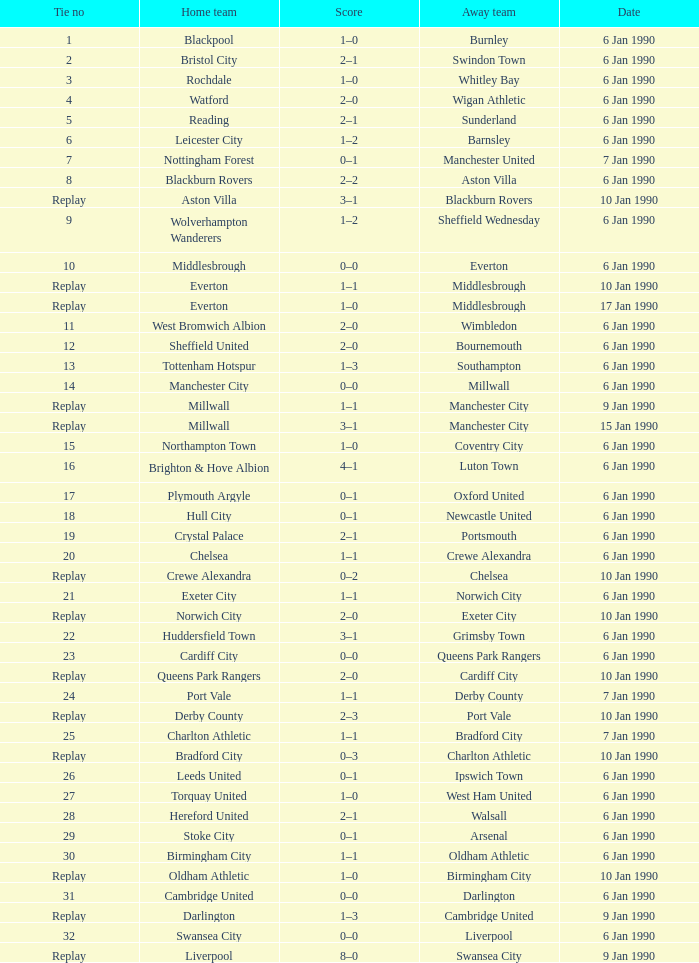What is the score of the game against away team exeter city on 10 jan 1990? 2–0. Can you parse all the data within this table? {'header': ['Tie no', 'Home team', 'Score', 'Away team', 'Date'], 'rows': [['1', 'Blackpool', '1–0', 'Burnley', '6 Jan 1990'], ['2', 'Bristol City', '2–1', 'Swindon Town', '6 Jan 1990'], ['3', 'Rochdale', '1–0', 'Whitley Bay', '6 Jan 1990'], ['4', 'Watford', '2–0', 'Wigan Athletic', '6 Jan 1990'], ['5', 'Reading', '2–1', 'Sunderland', '6 Jan 1990'], ['6', 'Leicester City', '1–2', 'Barnsley', '6 Jan 1990'], ['7', 'Nottingham Forest', '0–1', 'Manchester United', '7 Jan 1990'], ['8', 'Blackburn Rovers', '2–2', 'Aston Villa', '6 Jan 1990'], ['Replay', 'Aston Villa', '3–1', 'Blackburn Rovers', '10 Jan 1990'], ['9', 'Wolverhampton Wanderers', '1–2', 'Sheffield Wednesday', '6 Jan 1990'], ['10', 'Middlesbrough', '0–0', 'Everton', '6 Jan 1990'], ['Replay', 'Everton', '1–1', 'Middlesbrough', '10 Jan 1990'], ['Replay', 'Everton', '1–0', 'Middlesbrough', '17 Jan 1990'], ['11', 'West Bromwich Albion', '2–0', 'Wimbledon', '6 Jan 1990'], ['12', 'Sheffield United', '2–0', 'Bournemouth', '6 Jan 1990'], ['13', 'Tottenham Hotspur', '1–3', 'Southampton', '6 Jan 1990'], ['14', 'Manchester City', '0–0', 'Millwall', '6 Jan 1990'], ['Replay', 'Millwall', '1–1', 'Manchester City', '9 Jan 1990'], ['Replay', 'Millwall', '3–1', 'Manchester City', '15 Jan 1990'], ['15', 'Northampton Town', '1–0', 'Coventry City', '6 Jan 1990'], ['16', 'Brighton & Hove Albion', '4–1', 'Luton Town', '6 Jan 1990'], ['17', 'Plymouth Argyle', '0–1', 'Oxford United', '6 Jan 1990'], ['18', 'Hull City', '0–1', 'Newcastle United', '6 Jan 1990'], ['19', 'Crystal Palace', '2–1', 'Portsmouth', '6 Jan 1990'], ['20', 'Chelsea', '1–1', 'Crewe Alexandra', '6 Jan 1990'], ['Replay', 'Crewe Alexandra', '0–2', 'Chelsea', '10 Jan 1990'], ['21', 'Exeter City', '1–1', 'Norwich City', '6 Jan 1990'], ['Replay', 'Norwich City', '2–0', 'Exeter City', '10 Jan 1990'], ['22', 'Huddersfield Town', '3–1', 'Grimsby Town', '6 Jan 1990'], ['23', 'Cardiff City', '0–0', 'Queens Park Rangers', '6 Jan 1990'], ['Replay', 'Queens Park Rangers', '2–0', 'Cardiff City', '10 Jan 1990'], ['24', 'Port Vale', '1–1', 'Derby County', '7 Jan 1990'], ['Replay', 'Derby County', '2–3', 'Port Vale', '10 Jan 1990'], ['25', 'Charlton Athletic', '1–1', 'Bradford City', '7 Jan 1990'], ['Replay', 'Bradford City', '0–3', 'Charlton Athletic', '10 Jan 1990'], ['26', 'Leeds United', '0–1', 'Ipswich Town', '6 Jan 1990'], ['27', 'Torquay United', '1–0', 'West Ham United', '6 Jan 1990'], ['28', 'Hereford United', '2–1', 'Walsall', '6 Jan 1990'], ['29', 'Stoke City', '0–1', 'Arsenal', '6 Jan 1990'], ['30', 'Birmingham City', '1–1', 'Oldham Athletic', '6 Jan 1990'], ['Replay', 'Oldham Athletic', '1–0', 'Birmingham City', '10 Jan 1990'], ['31', 'Cambridge United', '0–0', 'Darlington', '6 Jan 1990'], ['Replay', 'Darlington', '1–3', 'Cambridge United', '9 Jan 1990'], ['32', 'Swansea City', '0–0', 'Liverpool', '6 Jan 1990'], ['Replay', 'Liverpool', '8–0', 'Swansea City', '9 Jan 1990']]} 